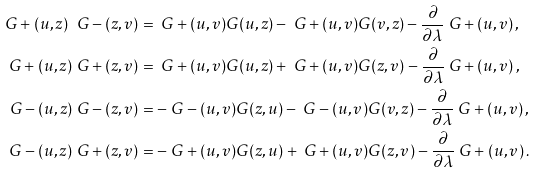<formula> <loc_0><loc_0><loc_500><loc_500>\ G + ( u , z ) \ G - ( z , v ) & = \ G + ( u , v ) G ( u , z ) - \ G + ( u , v ) G ( v , z ) - \frac { \partial } { \partial \lambda } \ G + ( u , v ) \, , \\ \ G + ( u , z ) \ G + ( z , v ) & = \ G + ( u , v ) G ( u , z ) + \ G + ( u , v ) G ( z , v ) - \frac { \partial } { \partial \lambda } \ G + ( u , v ) \, , \\ \ G - ( u , z ) \ G - ( z , v ) & = - \ G - ( u , v ) G ( z , u ) - \ G - ( u , v ) G ( v , z ) - \frac { \partial } { \partial \lambda } \ G + ( u , v ) \, , \\ \ G - ( u , z ) \ G + ( z , v ) & = - \ G + ( u , v ) G ( z , u ) + \ G + ( u , v ) G ( z , v ) - \frac { \partial } { \partial \lambda } \ G + ( u , v ) \, .</formula> 